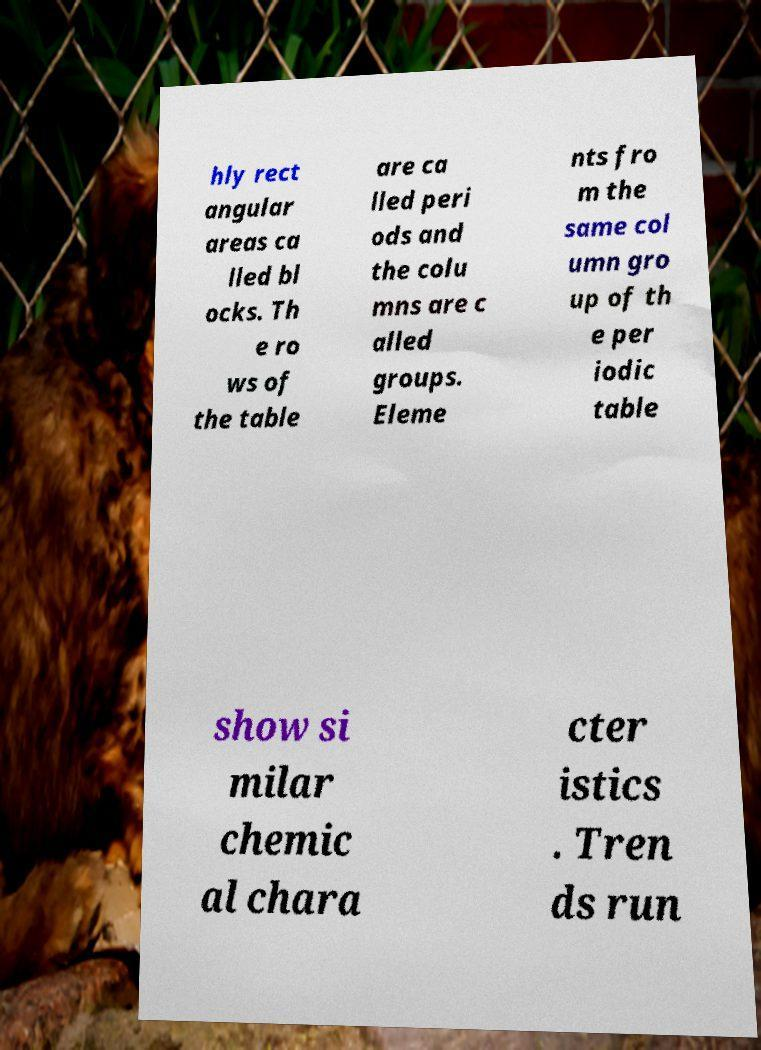Please read and relay the text visible in this image. What does it say? hly rect angular areas ca lled bl ocks. Th e ro ws of the table are ca lled peri ods and the colu mns are c alled groups. Eleme nts fro m the same col umn gro up of th e per iodic table show si milar chemic al chara cter istics . Tren ds run 